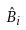Convert formula to latex. <formula><loc_0><loc_0><loc_500><loc_500>\hat { B } _ { i }</formula> 